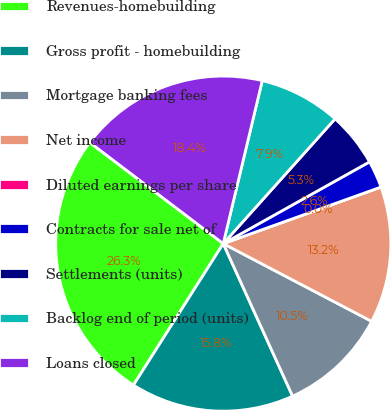Convert chart. <chart><loc_0><loc_0><loc_500><loc_500><pie_chart><fcel>Revenues-homebuilding<fcel>Gross profit - homebuilding<fcel>Mortgage banking fees<fcel>Net income<fcel>Diluted earnings per share<fcel>Contracts for sale net of<fcel>Settlements (units)<fcel>Backlog end of period (units)<fcel>Loans closed<nl><fcel>26.32%<fcel>15.79%<fcel>10.53%<fcel>13.16%<fcel>0.0%<fcel>2.63%<fcel>5.26%<fcel>7.89%<fcel>18.42%<nl></chart> 